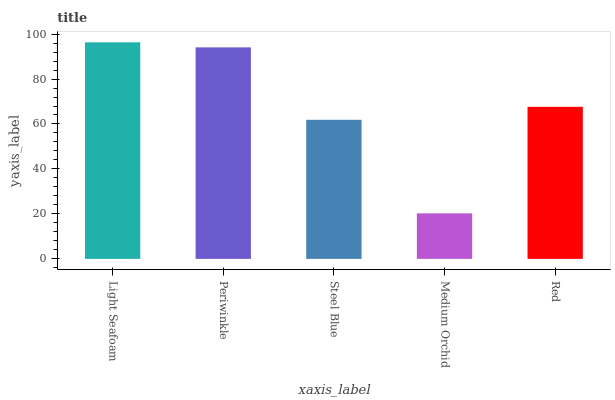Is Periwinkle the minimum?
Answer yes or no. No. Is Periwinkle the maximum?
Answer yes or no. No. Is Light Seafoam greater than Periwinkle?
Answer yes or no. Yes. Is Periwinkle less than Light Seafoam?
Answer yes or no. Yes. Is Periwinkle greater than Light Seafoam?
Answer yes or no. No. Is Light Seafoam less than Periwinkle?
Answer yes or no. No. Is Red the high median?
Answer yes or no. Yes. Is Red the low median?
Answer yes or no. Yes. Is Periwinkle the high median?
Answer yes or no. No. Is Medium Orchid the low median?
Answer yes or no. No. 